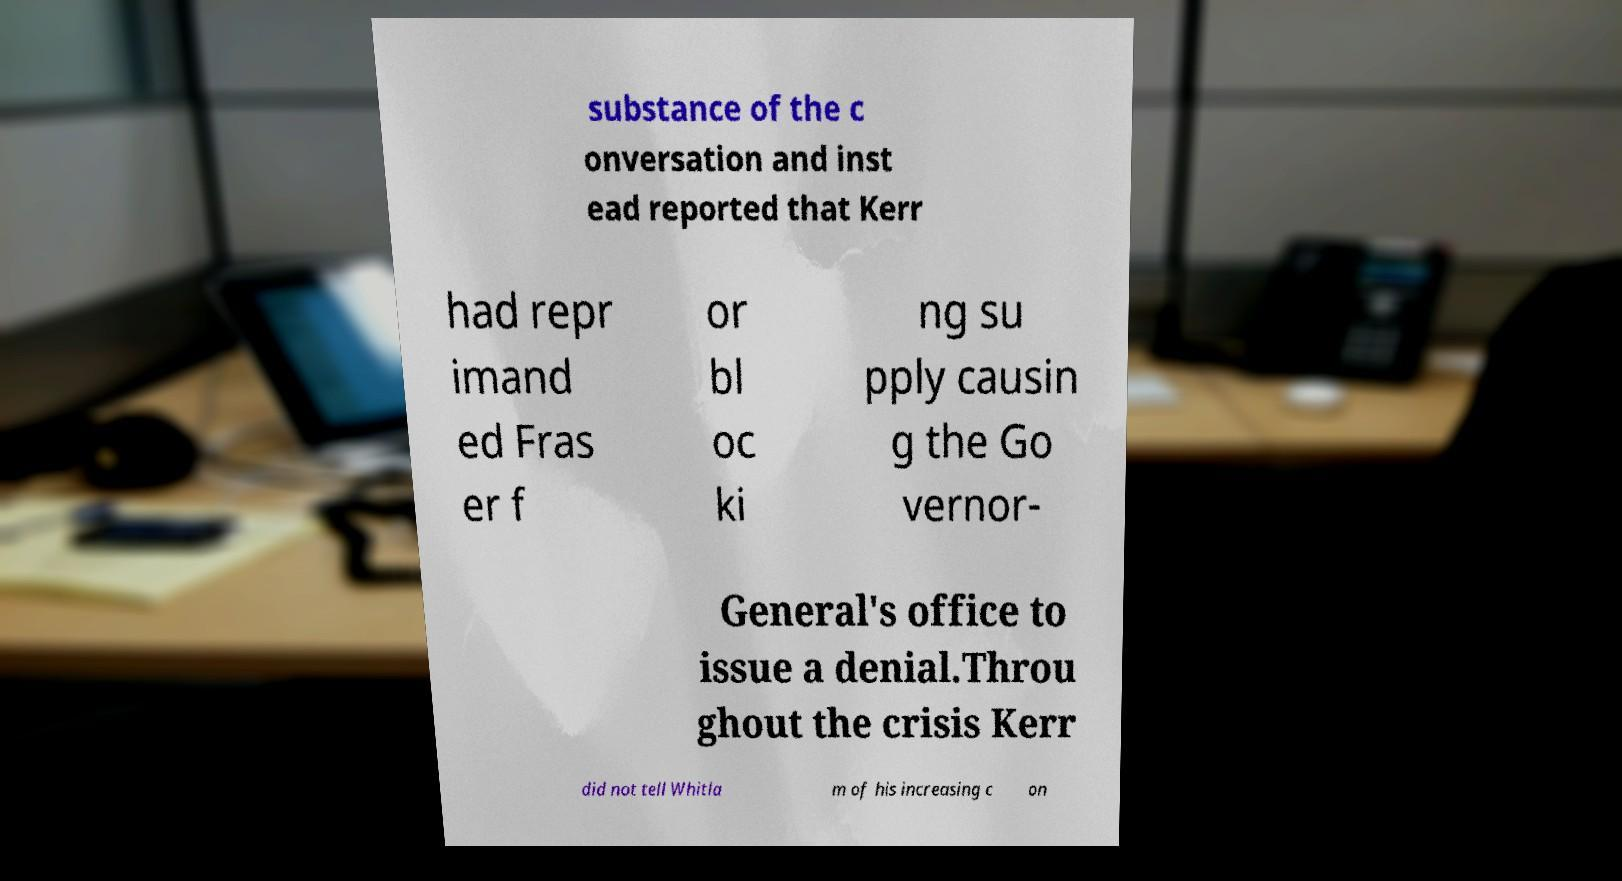Please identify and transcribe the text found in this image. substance of the c onversation and inst ead reported that Kerr had repr imand ed Fras er f or bl oc ki ng su pply causin g the Go vernor- General's office to issue a denial.Throu ghout the crisis Kerr did not tell Whitla m of his increasing c on 